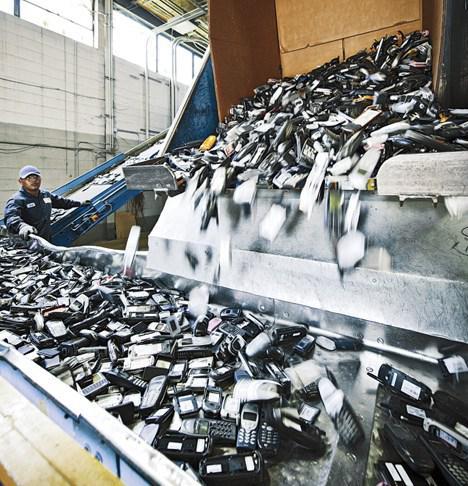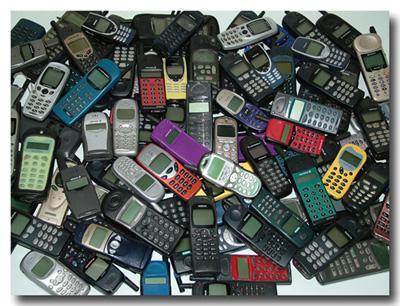The first image is the image on the left, the second image is the image on the right. Assess this claim about the two images: "The left image shows a pile of phones in a visible container with sides, and the right image shows a pile of phones - including at least two blue ones - with no container.". Correct or not? Answer yes or no. Yes. The first image is the image on the left, the second image is the image on the right. Analyze the images presented: Is the assertion "In at least one image there is one layer of phones laying on a white table." valid? Answer yes or no. Yes. 